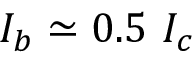Convert formula to latex. <formula><loc_0><loc_0><loc_500><loc_500>I _ { b } \simeq 0 . 5 I _ { c }</formula> 